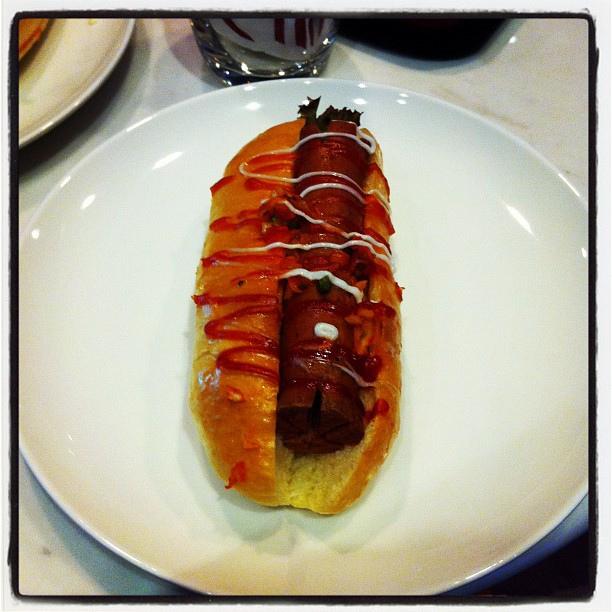Is there silverware in the picture?
Keep it brief. No. What color is the plate?
Be succinct. White. What condiments are on the hot dog?
Short answer required. Ketchup. 